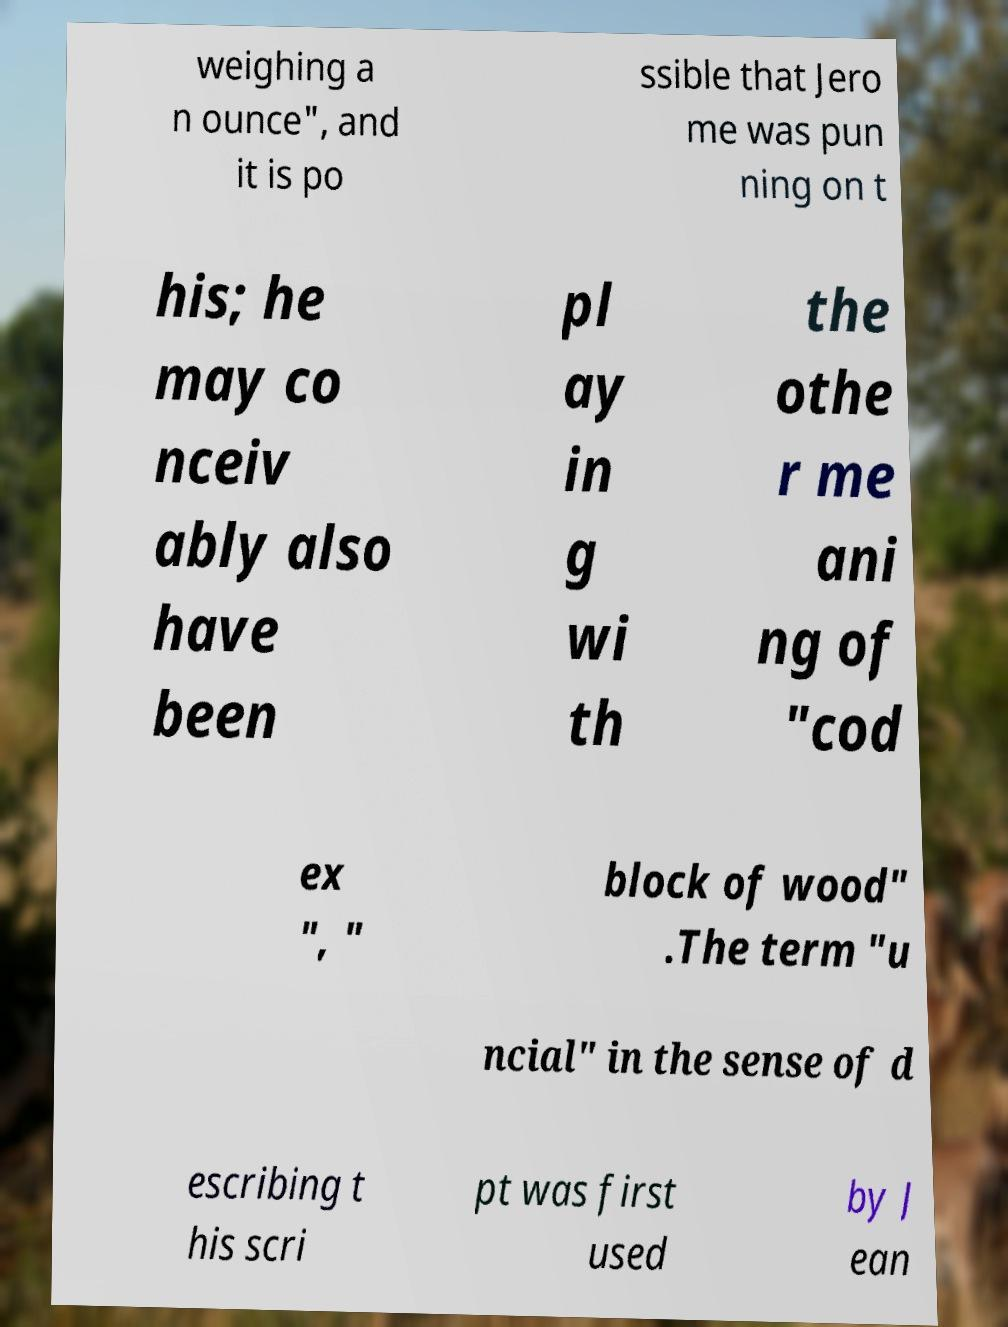What messages or text are displayed in this image? I need them in a readable, typed format. weighing a n ounce", and it is po ssible that Jero me was pun ning on t his; he may co nceiv ably also have been pl ay in g wi th the othe r me ani ng of "cod ex ", " block of wood" .The term "u ncial" in the sense of d escribing t his scri pt was first used by J ean 